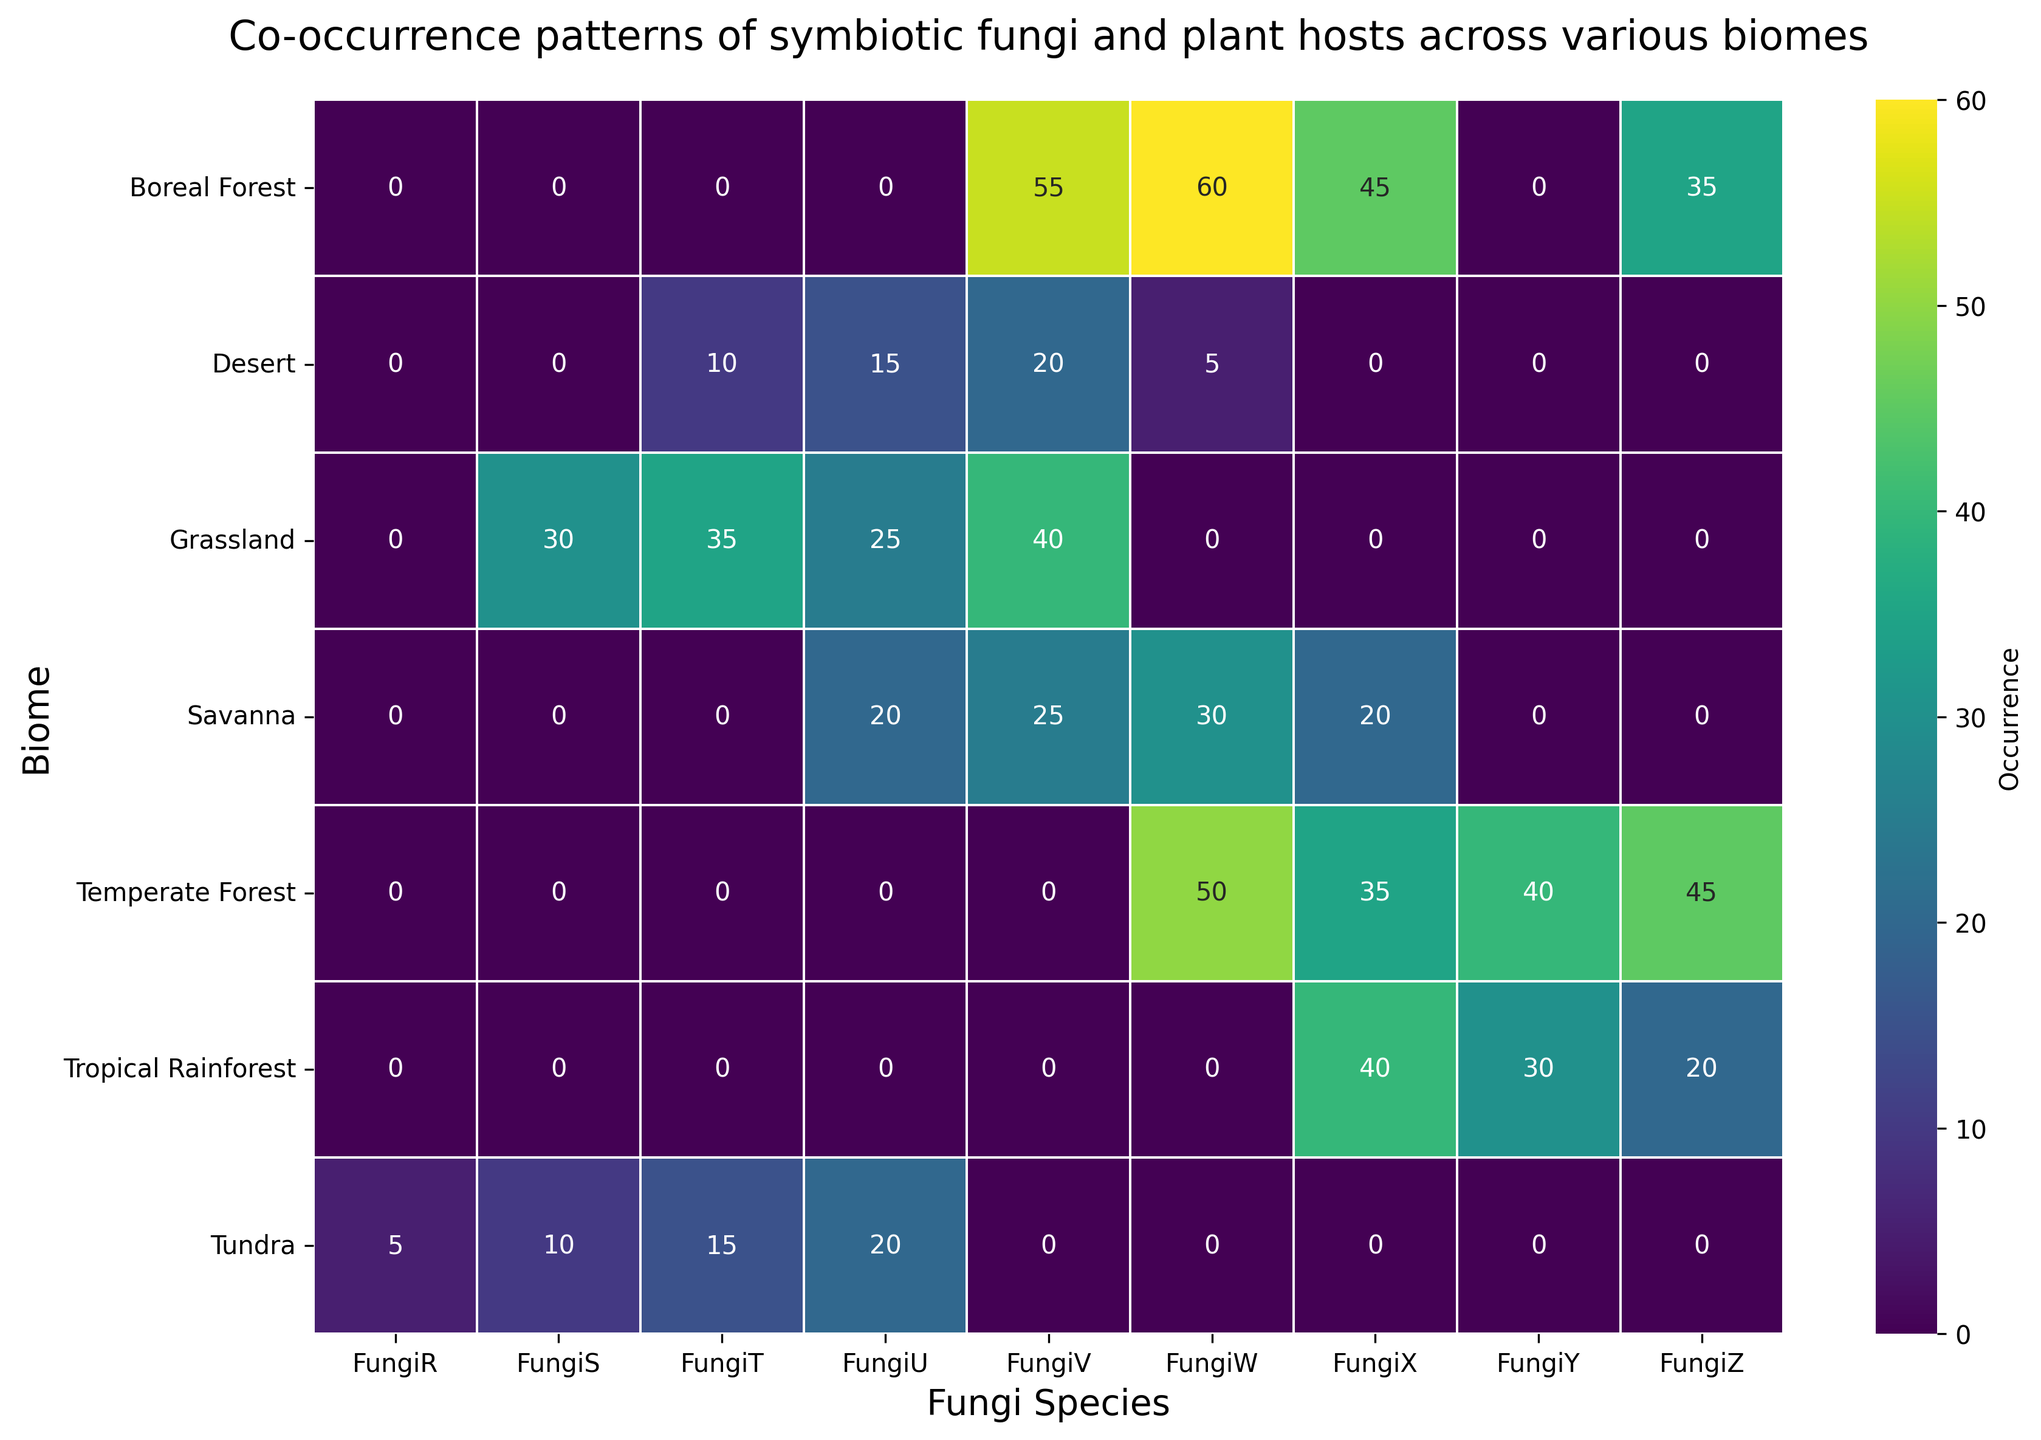What's the total occurrence of FungiX across all biomes? Sum the occurrences of FungiX across all rows in the heatmap: 25 (Tropical Rainforest) + 15 (Tropical Rainforest) + 35 (Temperate Forest) + 45 (Boreal Forest) + 20 (Savanna) = 140
Answer: 140 Which biome has the highest occurrence of FungiW and what is its occurrence? Identify the cells with FungiW and find the highest value: Tropical Rainforest (0), Temperate Forest (50), Boreal Forest (60), Savanna (30), Desert (5), Grassland (0), Tundra (0). The highest occurrence is 60 in the Boreal Forest.
Answer: Boreal Forest, 60 How does the occurrence of FungiT in the Grassland compare to its occurrence in the Desert? Compare the occurrence of FungiT: Grassland (35) vs. Desert (10). 35 is greater than 10.
Answer: Grassland has a higher occurrence, 35 vs. 10 What is the sum of occurrences of FungiU in the Savanna and Tundra? Sum the occurrences in Savanna and Tundra: Savanna (25) + Tundra (20) = 45
Answer: 45 Which biome has the lowest occurrence of FungiR, and what is its occurrence? Check the occurrences of FungiR across all biomes: only Tundra has FungiR, with an occurrence of 5.
Answer: Tundra, 5 What is the average occurrence of FungiS across all biomes? Find the total occurrence of FungiS and the number of biomes it occurs in: Grassland (30) + Tundra (10) = 40, average = 40/2 = 20
Answer: 20 In which biome does FungiV occur more frequently, Grassland or Boreal Forest? Compare the occurrences of FungiV: Grassland (40) vs. Boreal Forest (55). 55 is greater than 40.
Answer: Boreal Forest Visualize the color pattern for FungiZ; in which biome does it have a dark shade? Identify the darkest shade among the occurrences of FungiZ: Tropical Rainforest (20), Temperate Forest (45), Boreal Forest (35). The darkest shade corresponds to 45 in Temperate Forest.
Answer: Temperate Forest What is the total occurrence of all fungi species in the Desert biome? Sum the occurrences of all fungi species in Desert: 10 (FungiT) + 15 (FungiU) + 20 (FungiV) + 5 (FungiW) = 50
Answer: 50 If we consider only biomes with occurrences of FungiU, what is their combined total? Sum the occurrences of FungiU: Savanna (25), Desert (15), Tundra (20) = 25 + 15 + 20 = 60
Answer: 60 